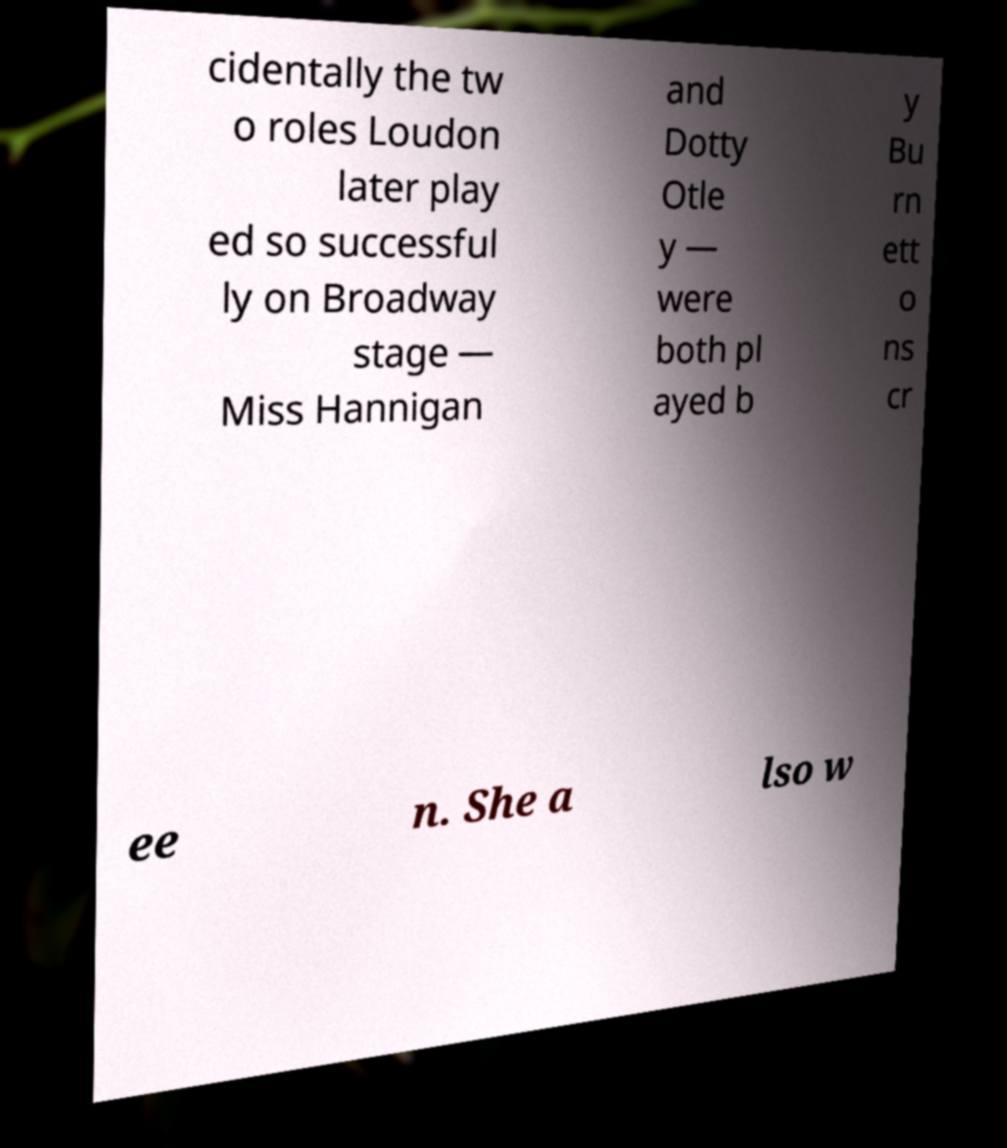There's text embedded in this image that I need extracted. Can you transcribe it verbatim? cidentally the tw o roles Loudon later play ed so successful ly on Broadway stage — Miss Hannigan and Dotty Otle y — were both pl ayed b y Bu rn ett o ns cr ee n. She a lso w 